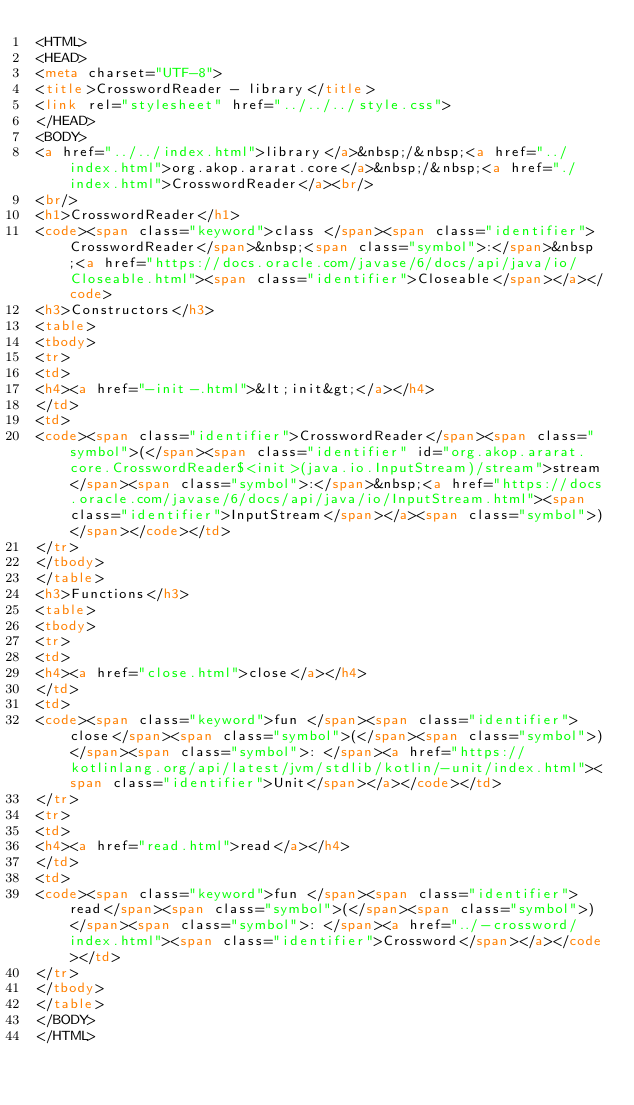<code> <loc_0><loc_0><loc_500><loc_500><_HTML_><HTML>
<HEAD>
<meta charset="UTF-8">
<title>CrosswordReader - library</title>
<link rel="stylesheet" href="../../../style.css">
</HEAD>
<BODY>
<a href="../../index.html">library</a>&nbsp;/&nbsp;<a href="../index.html">org.akop.ararat.core</a>&nbsp;/&nbsp;<a href="./index.html">CrosswordReader</a><br/>
<br/>
<h1>CrosswordReader</h1>
<code><span class="keyword">class </span><span class="identifier">CrosswordReader</span>&nbsp;<span class="symbol">:</span>&nbsp;<a href="https://docs.oracle.com/javase/6/docs/api/java/io/Closeable.html"><span class="identifier">Closeable</span></a></code>
<h3>Constructors</h3>
<table>
<tbody>
<tr>
<td>
<h4><a href="-init-.html">&lt;init&gt;</a></h4>
</td>
<td>
<code><span class="identifier">CrosswordReader</span><span class="symbol">(</span><span class="identifier" id="org.akop.ararat.core.CrosswordReader$<init>(java.io.InputStream)/stream">stream</span><span class="symbol">:</span>&nbsp;<a href="https://docs.oracle.com/javase/6/docs/api/java/io/InputStream.html"><span class="identifier">InputStream</span></a><span class="symbol">)</span></code></td>
</tr>
</tbody>
</table>
<h3>Functions</h3>
<table>
<tbody>
<tr>
<td>
<h4><a href="close.html">close</a></h4>
</td>
<td>
<code><span class="keyword">fun </span><span class="identifier">close</span><span class="symbol">(</span><span class="symbol">)</span><span class="symbol">: </span><a href="https://kotlinlang.org/api/latest/jvm/stdlib/kotlin/-unit/index.html"><span class="identifier">Unit</span></a></code></td>
</tr>
<tr>
<td>
<h4><a href="read.html">read</a></h4>
</td>
<td>
<code><span class="keyword">fun </span><span class="identifier">read</span><span class="symbol">(</span><span class="symbol">)</span><span class="symbol">: </span><a href="../-crossword/index.html"><span class="identifier">Crossword</span></a></code></td>
</tr>
</tbody>
</table>
</BODY>
</HTML>
</code> 